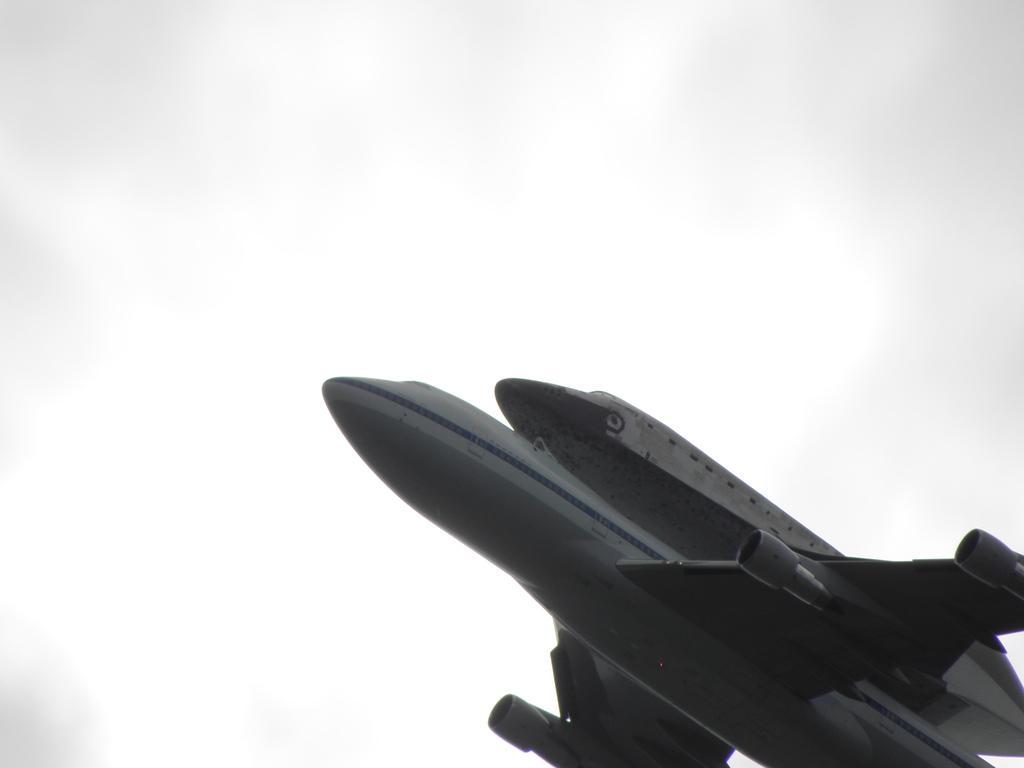In one or two sentences, can you explain what this image depicts? In the image we can see a plane. Behind the plane there is sky. 